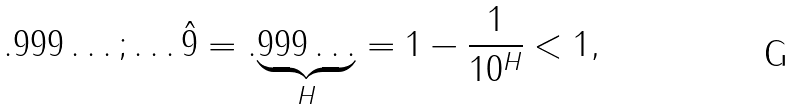<formula> <loc_0><loc_0><loc_500><loc_500>. 9 9 9 \dots ; \dots \hat { 9 } = . \underset { H } { \underbrace { 9 9 9 \dots } } = 1 - \frac { 1 } { 1 0 ^ { H } } < 1 ,</formula> 